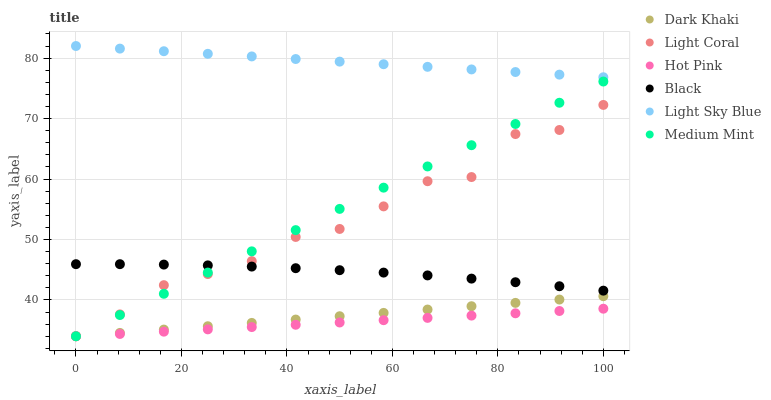Does Hot Pink have the minimum area under the curve?
Answer yes or no. Yes. Does Light Sky Blue have the maximum area under the curve?
Answer yes or no. Yes. Does Light Coral have the minimum area under the curve?
Answer yes or no. No. Does Light Coral have the maximum area under the curve?
Answer yes or no. No. Is Dark Khaki the smoothest?
Answer yes or no. Yes. Is Light Coral the roughest?
Answer yes or no. Yes. Is Hot Pink the smoothest?
Answer yes or no. No. Is Hot Pink the roughest?
Answer yes or no. No. Does Medium Mint have the lowest value?
Answer yes or no. Yes. Does Light Sky Blue have the lowest value?
Answer yes or no. No. Does Light Sky Blue have the highest value?
Answer yes or no. Yes. Does Light Coral have the highest value?
Answer yes or no. No. Is Medium Mint less than Light Sky Blue?
Answer yes or no. Yes. Is Light Sky Blue greater than Dark Khaki?
Answer yes or no. Yes. Does Hot Pink intersect Medium Mint?
Answer yes or no. Yes. Is Hot Pink less than Medium Mint?
Answer yes or no. No. Is Hot Pink greater than Medium Mint?
Answer yes or no. No. Does Medium Mint intersect Light Sky Blue?
Answer yes or no. No. 